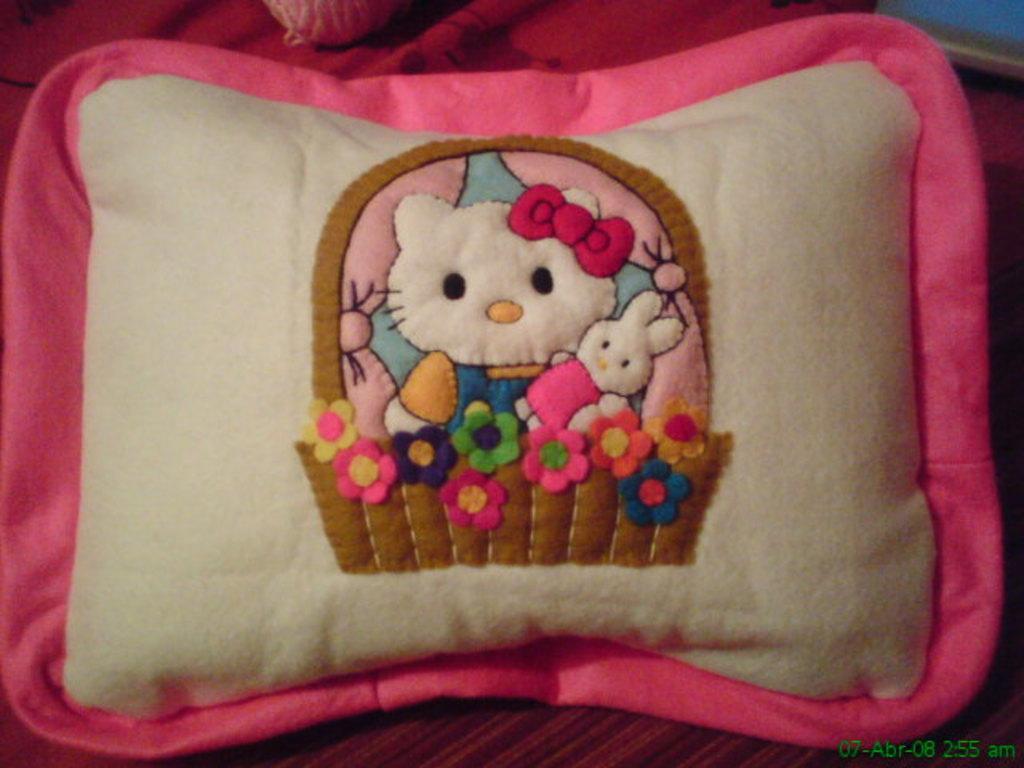In one or two sentences, can you explain what this image depicts? In this image I can see a pillow which is in white and pink color, on the pillow I can see two dolls and few flowers in multicolor. 